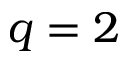<formula> <loc_0><loc_0><loc_500><loc_500>q = 2</formula> 